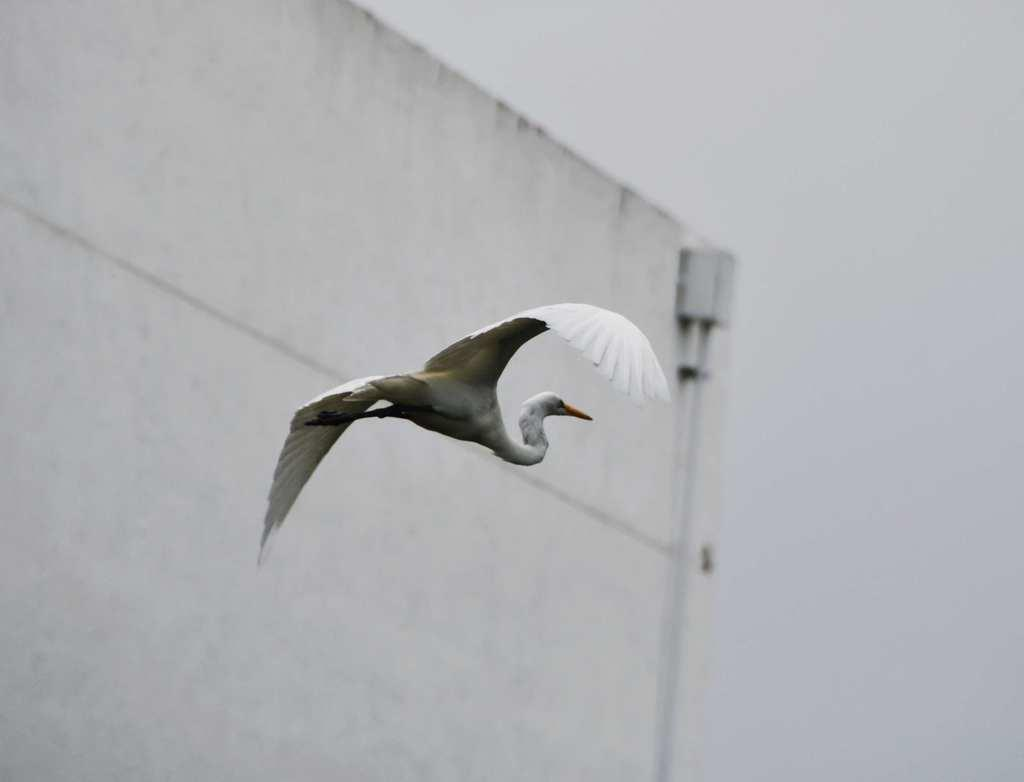What type of animal is in the image? There is a bird in the image. What is the bird doing in the image? The bird is in the air. What color is the bird? The bird is white in color. What is visible in the background of the image? The background of the image is the sky. What color is the sky in the image? The sky is white in color. What type of substance is the bird reading in the image? There is no substance or reading activity present in the image; it features a bird in the air. 